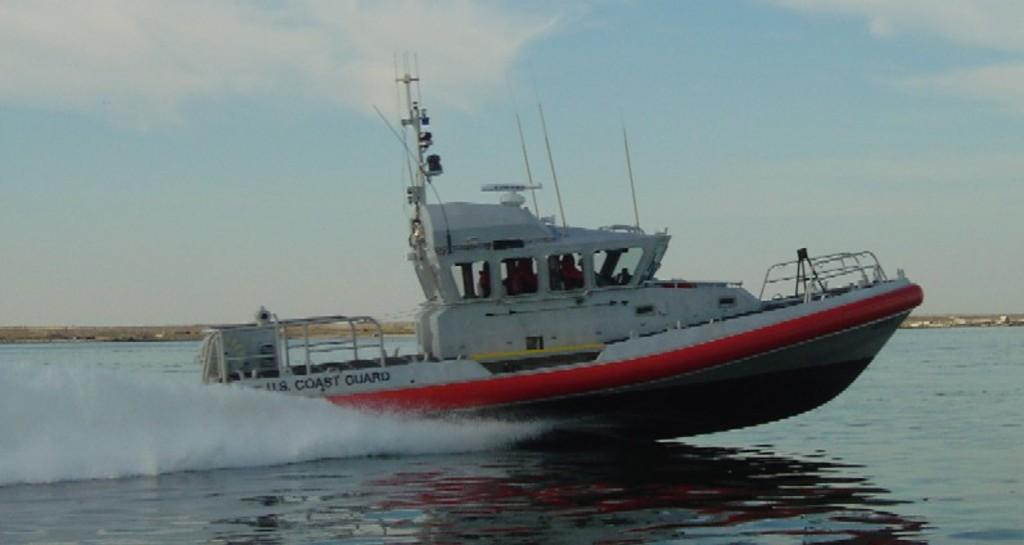What is the main subject of the image? There is a ship in the image. Where is the ship located? The ship is sailing in an ocean. What can be seen in the background of the image? The sky is visible in the background of the image. Can you see a tiger at the zoo in the image? There is no zoo or tiger present in the image; it features a ship sailing in an ocean. 